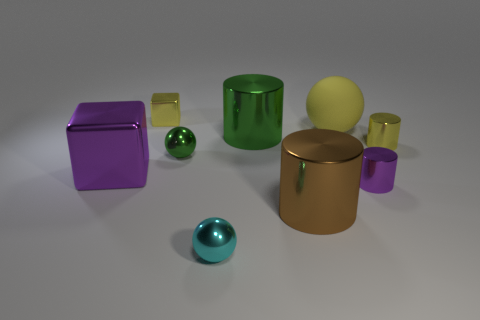How many big shiny objects are to the left of the brown metal cylinder and right of the cyan object?
Your answer should be compact. 1. What number of things are either yellow spheres or yellow metal things in front of the green shiny cylinder?
Provide a succinct answer. 2. There is a cyan sphere that is made of the same material as the purple cube; what size is it?
Provide a succinct answer. Small. There is a metallic object left of the yellow shiny thing left of the tiny cyan thing; what shape is it?
Offer a very short reply. Cube. How many gray things are tiny blocks or balls?
Provide a short and direct response. 0. There is a metal thing to the left of the yellow metallic thing behind the large green cylinder; are there any purple objects that are in front of it?
Provide a short and direct response. Yes. There is a large object that is the same color as the tiny cube; what shape is it?
Keep it short and to the point. Sphere. Is there any other thing that is made of the same material as the small green object?
Give a very brief answer. Yes. How many small things are gray rubber balls or yellow blocks?
Offer a very short reply. 1. Does the purple metal thing on the right side of the large metallic block have the same shape as the cyan object?
Provide a succinct answer. No. 